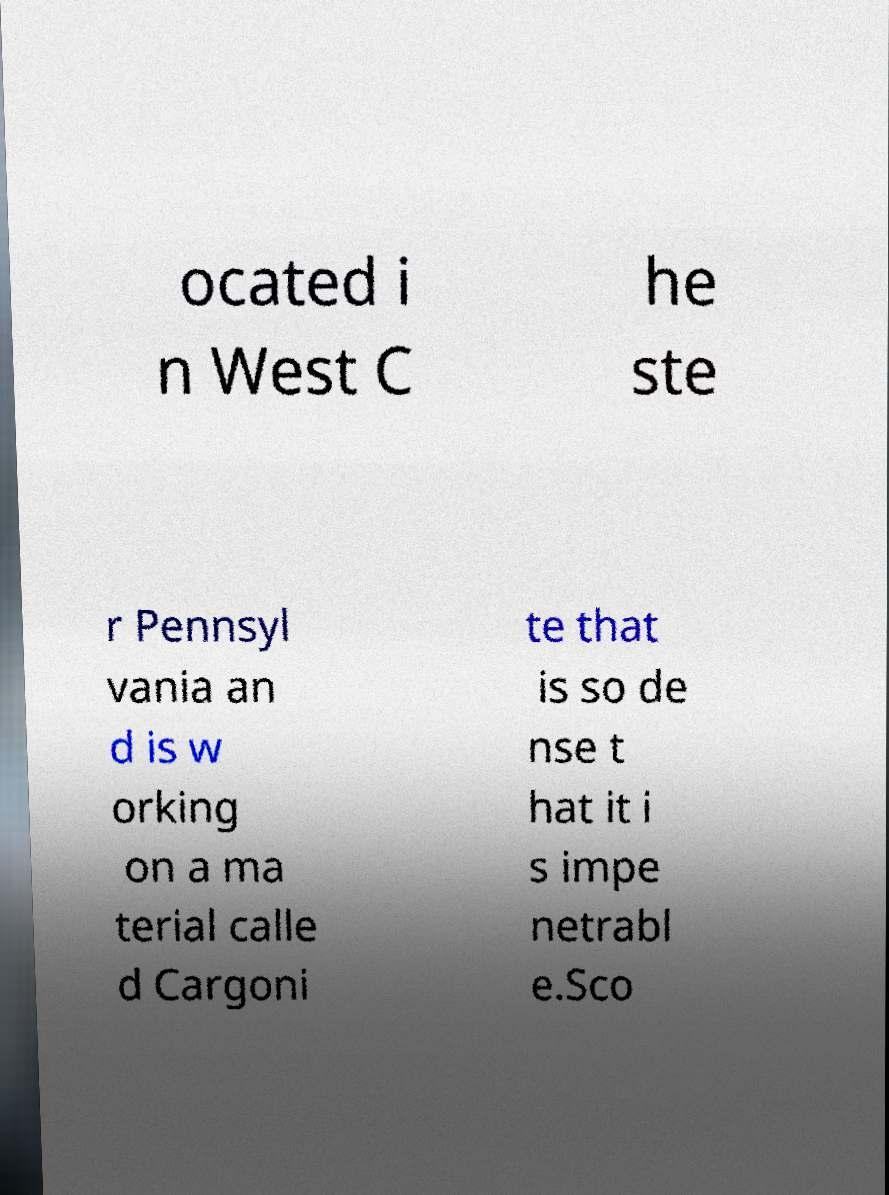Can you accurately transcribe the text from the provided image for me? ocated i n West C he ste r Pennsyl vania an d is w orking on a ma terial calle d Cargoni te that is so de nse t hat it i s impe netrabl e.Sco 